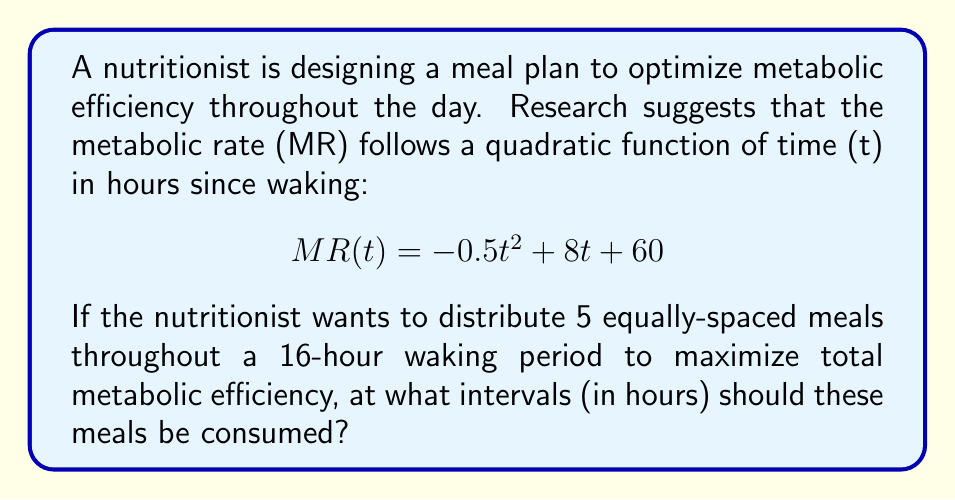Help me with this question. 1) First, we need to find the optimal spacing between meals. With 5 meals over 16 hours, we have 4 equal intervals:

   $$ \text{Interval} = \frac{16\text{ hours}}{4\text{ intervals}} = 4\text{ hours} $$

2) Now, we need to determine the timing of each meal. Let's call the times t1, t2, t3, t4, and t5:

   t1 = 0 (immediately upon waking)
   t2 = 4 hours
   t3 = 8 hours
   t4 = 12 hours
   t5 = 16 hours

3) To maximize metabolic efficiency, we want to consume meals when the metabolic rate is highest. We can find this by calculating the MR at each meal time:

   $$ MR(0) = -0.5(0)^2 + 8(0) + 60 = 60 $$
   $$ MR(4) = -0.5(4)^2 + 8(4) + 60 = 84 $$
   $$ MR(8) = -0.5(8)^2 + 8(8) + 60 = 92 $$
   $$ MR(12) = -0.5(12)^2 + 8(12) + 60 = 84 $$
   $$ MR(16) = -0.5(16)^2 + 8(16) + 60 = 60 $$

4) We can see that the metabolic rate peaks at t = 8 hours, which coincides with the middle meal (t3).

5) This distribution ensures that meals are consumed when metabolic rate is highest, thus maximizing metabolic efficiency throughout the day.
Answer: 4 hours 